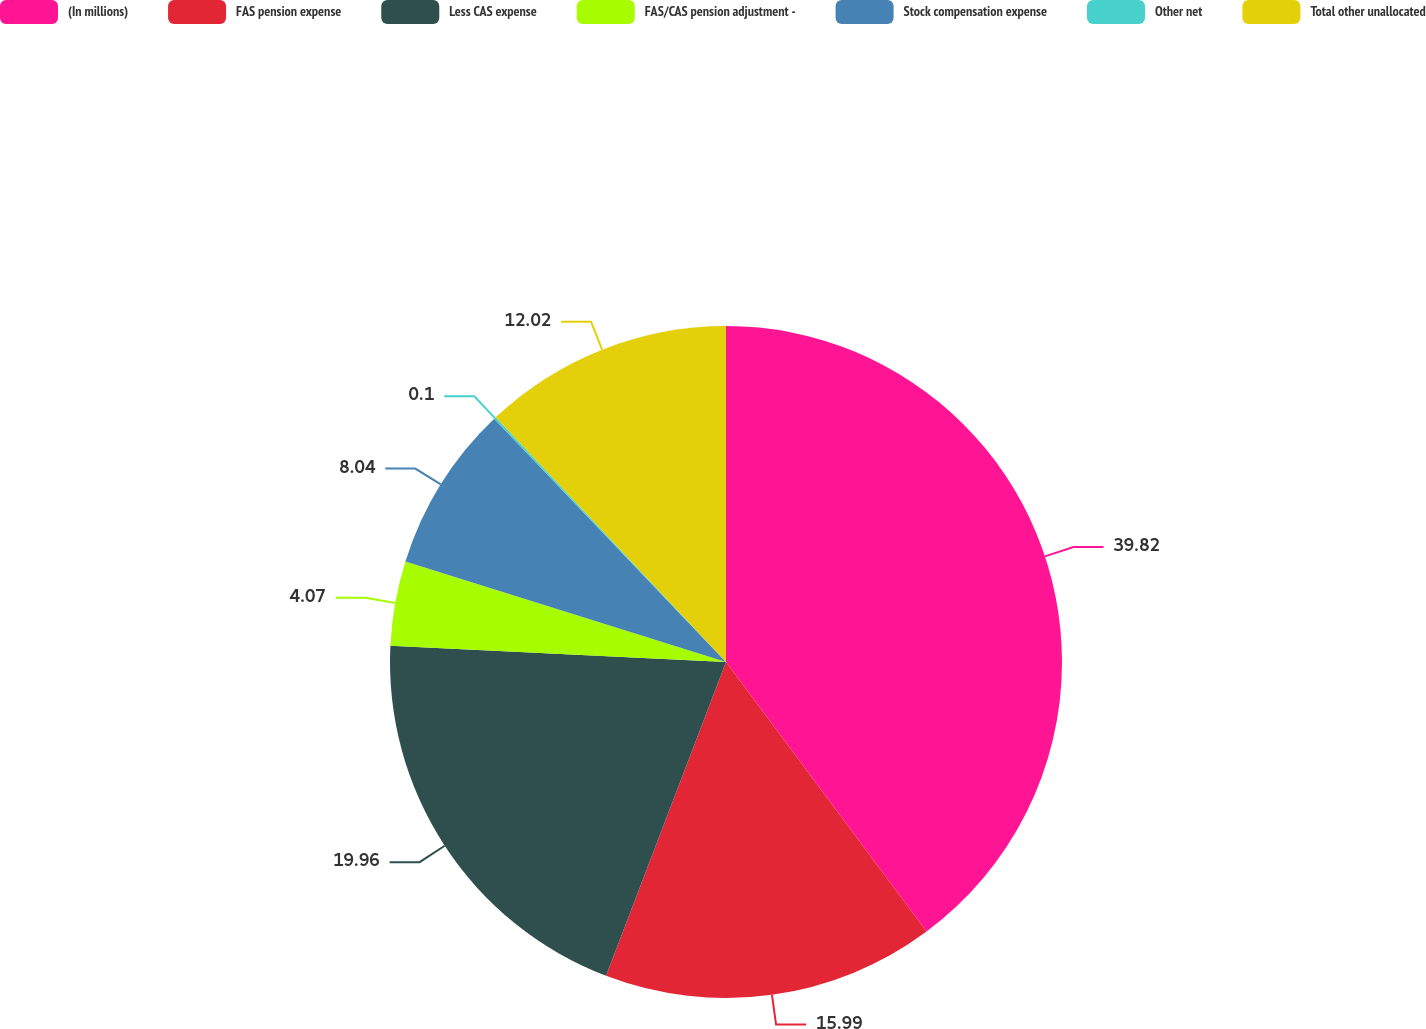Convert chart to OTSL. <chart><loc_0><loc_0><loc_500><loc_500><pie_chart><fcel>(In millions)<fcel>FAS pension expense<fcel>Less CAS expense<fcel>FAS/CAS pension adjustment -<fcel>Stock compensation expense<fcel>Other net<fcel>Total other unallocated<nl><fcel>39.82%<fcel>15.99%<fcel>19.96%<fcel>4.07%<fcel>8.04%<fcel>0.1%<fcel>12.02%<nl></chart> 